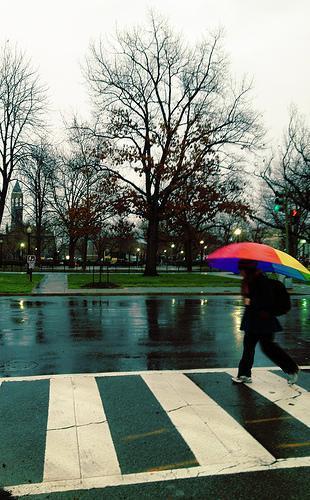How many people do you see?
Give a very brief answer. 1. How many umbrellas are in the picture?
Give a very brief answer. 1. 